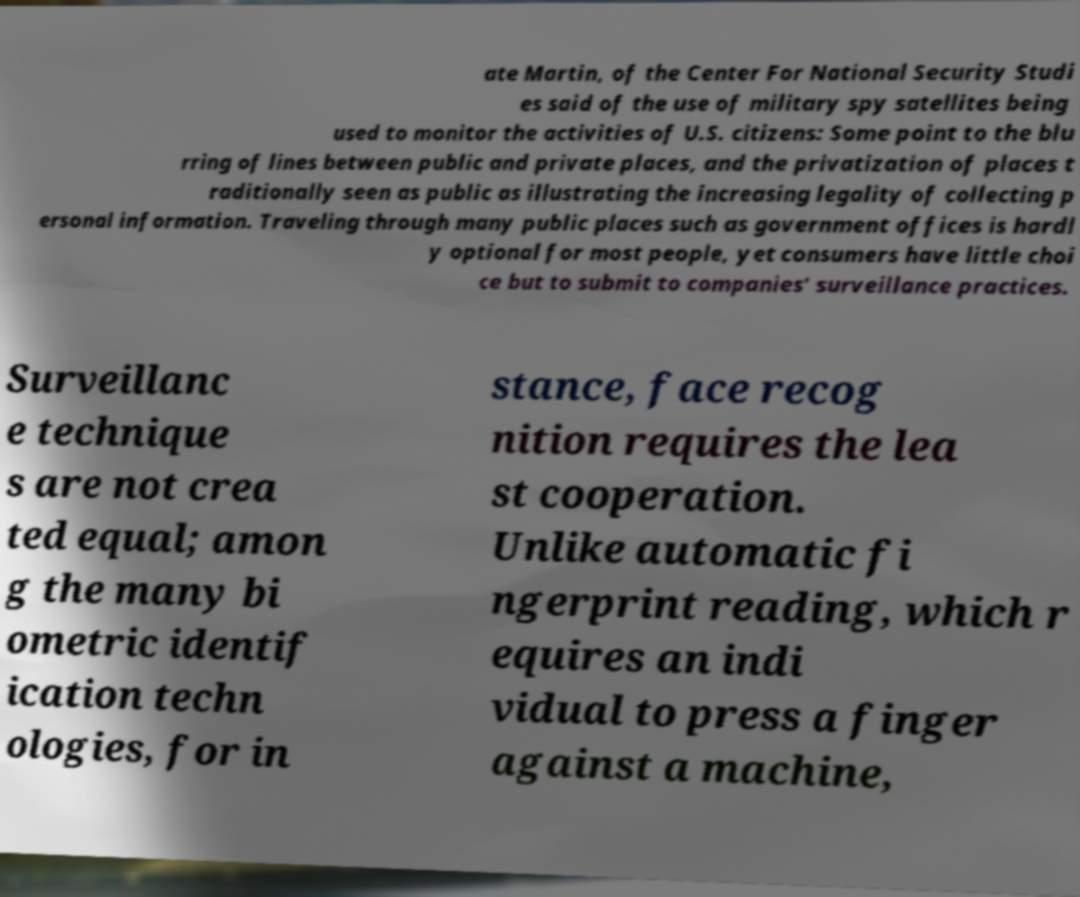There's text embedded in this image that I need extracted. Can you transcribe it verbatim? ate Martin, of the Center For National Security Studi es said of the use of military spy satellites being used to monitor the activities of U.S. citizens: Some point to the blu rring of lines between public and private places, and the privatization of places t raditionally seen as public as illustrating the increasing legality of collecting p ersonal information. Traveling through many public places such as government offices is hardl y optional for most people, yet consumers have little choi ce but to submit to companies' surveillance practices. Surveillanc e technique s are not crea ted equal; amon g the many bi ometric identif ication techn ologies, for in stance, face recog nition requires the lea st cooperation. Unlike automatic fi ngerprint reading, which r equires an indi vidual to press a finger against a machine, 